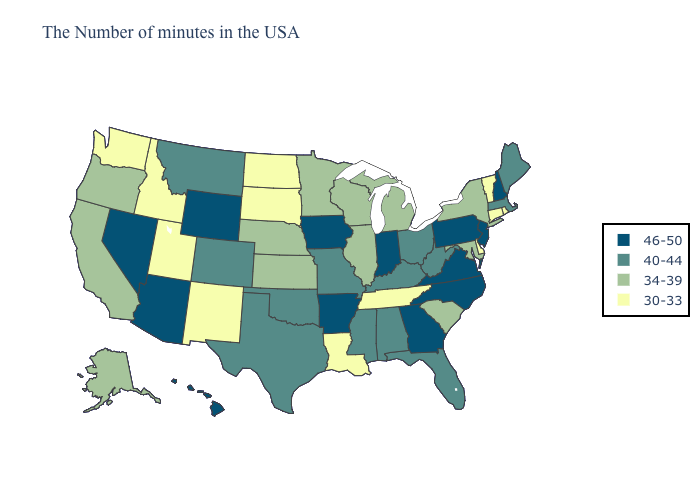How many symbols are there in the legend?
Keep it brief. 4. Does Iowa have the highest value in the MidWest?
Give a very brief answer. Yes. Name the states that have a value in the range 46-50?
Concise answer only. New Hampshire, New Jersey, Pennsylvania, Virginia, North Carolina, Georgia, Indiana, Arkansas, Iowa, Wyoming, Arizona, Nevada, Hawaii. Among the states that border South Carolina , which have the highest value?
Quick response, please. North Carolina, Georgia. What is the value of Mississippi?
Be succinct. 40-44. What is the lowest value in the USA?
Short answer required. 30-33. Among the states that border Maryland , does West Virginia have the lowest value?
Quick response, please. No. Name the states that have a value in the range 34-39?
Be succinct. New York, Maryland, South Carolina, Michigan, Wisconsin, Illinois, Minnesota, Kansas, Nebraska, California, Oregon, Alaska. Name the states that have a value in the range 46-50?
Write a very short answer. New Hampshire, New Jersey, Pennsylvania, Virginia, North Carolina, Georgia, Indiana, Arkansas, Iowa, Wyoming, Arizona, Nevada, Hawaii. Does Texas have a lower value than Montana?
Be succinct. No. Name the states that have a value in the range 46-50?
Short answer required. New Hampshire, New Jersey, Pennsylvania, Virginia, North Carolina, Georgia, Indiana, Arkansas, Iowa, Wyoming, Arizona, Nevada, Hawaii. Which states hav the highest value in the West?
Answer briefly. Wyoming, Arizona, Nevada, Hawaii. What is the value of Florida?
Quick response, please. 40-44. What is the highest value in the USA?
Give a very brief answer. 46-50. Name the states that have a value in the range 30-33?
Keep it brief. Rhode Island, Vermont, Connecticut, Delaware, Tennessee, Louisiana, South Dakota, North Dakota, New Mexico, Utah, Idaho, Washington. 